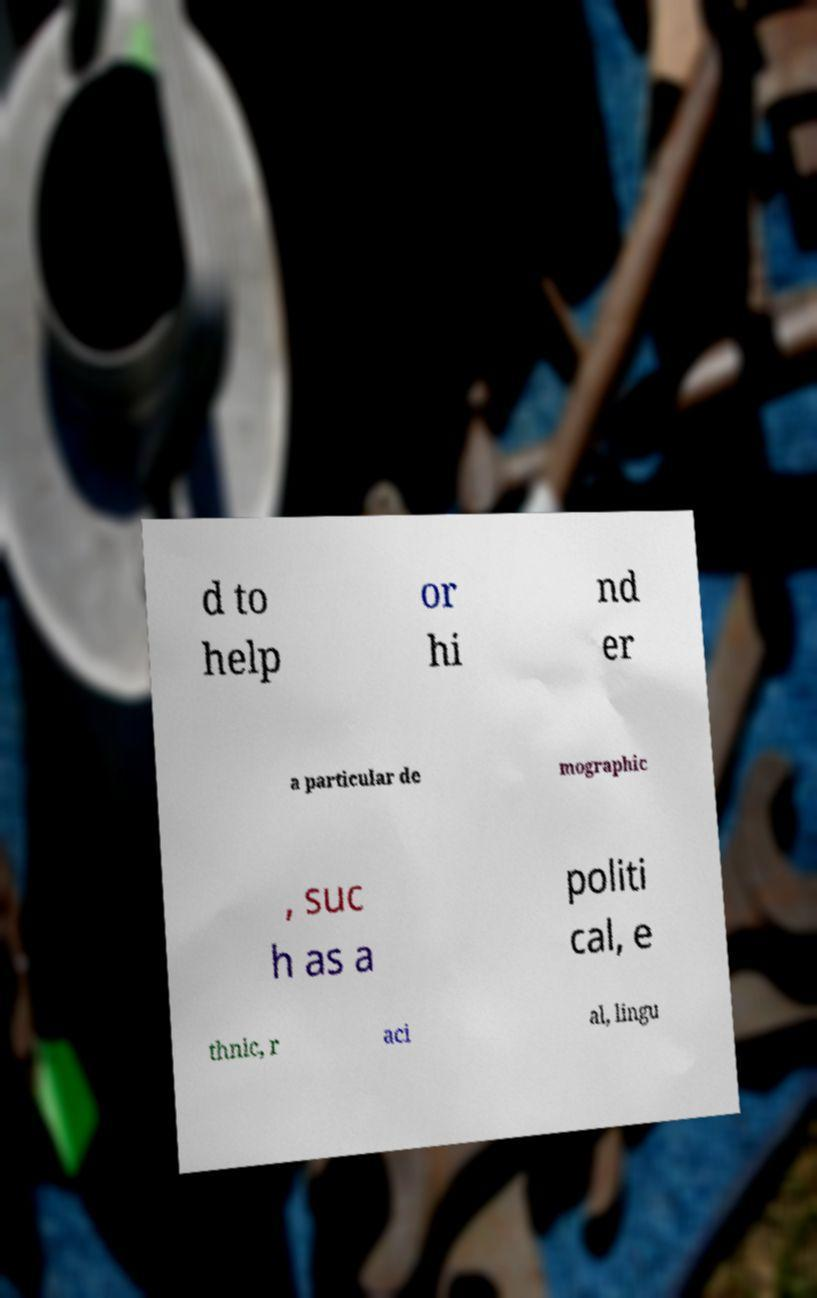What messages or text are displayed in this image? I need them in a readable, typed format. d to help or hi nd er a particular de mographic , suc h as a politi cal, e thnic, r aci al, lingu 